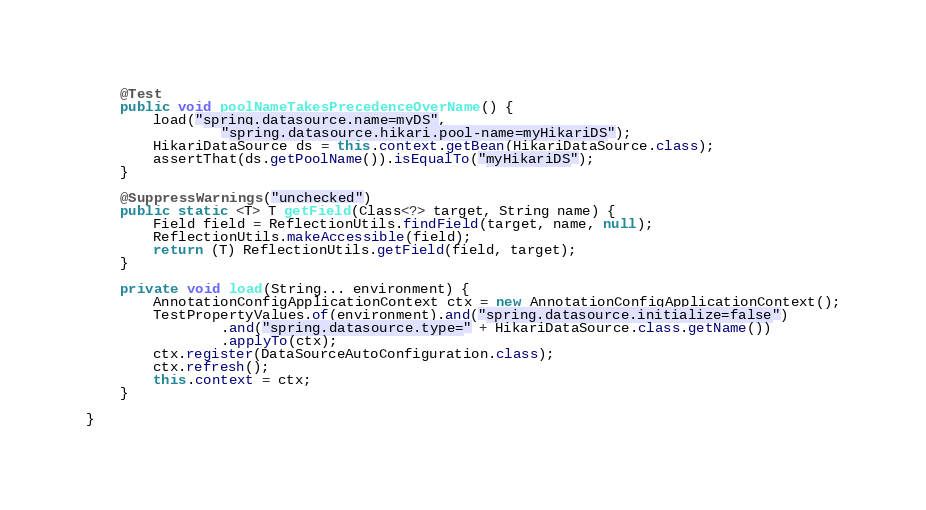Convert code to text. <code><loc_0><loc_0><loc_500><loc_500><_Java_>
	@Test
	public void poolNameTakesPrecedenceOverName() {
		load("spring.datasource.name=myDS",
				"spring.datasource.hikari.pool-name=myHikariDS");
		HikariDataSource ds = this.context.getBean(HikariDataSource.class);
		assertThat(ds.getPoolName()).isEqualTo("myHikariDS");
	}

	@SuppressWarnings("unchecked")
	public static <T> T getField(Class<?> target, String name) {
		Field field = ReflectionUtils.findField(target, name, null);
		ReflectionUtils.makeAccessible(field);
		return (T) ReflectionUtils.getField(field, target);
	}

	private void load(String... environment) {
		AnnotationConfigApplicationContext ctx = new AnnotationConfigApplicationContext();
		TestPropertyValues.of(environment).and("spring.datasource.initialize=false")
				.and("spring.datasource.type=" + HikariDataSource.class.getName())
				.applyTo(ctx);
		ctx.register(DataSourceAutoConfiguration.class);
		ctx.refresh();
		this.context = ctx;
	}

}
</code> 